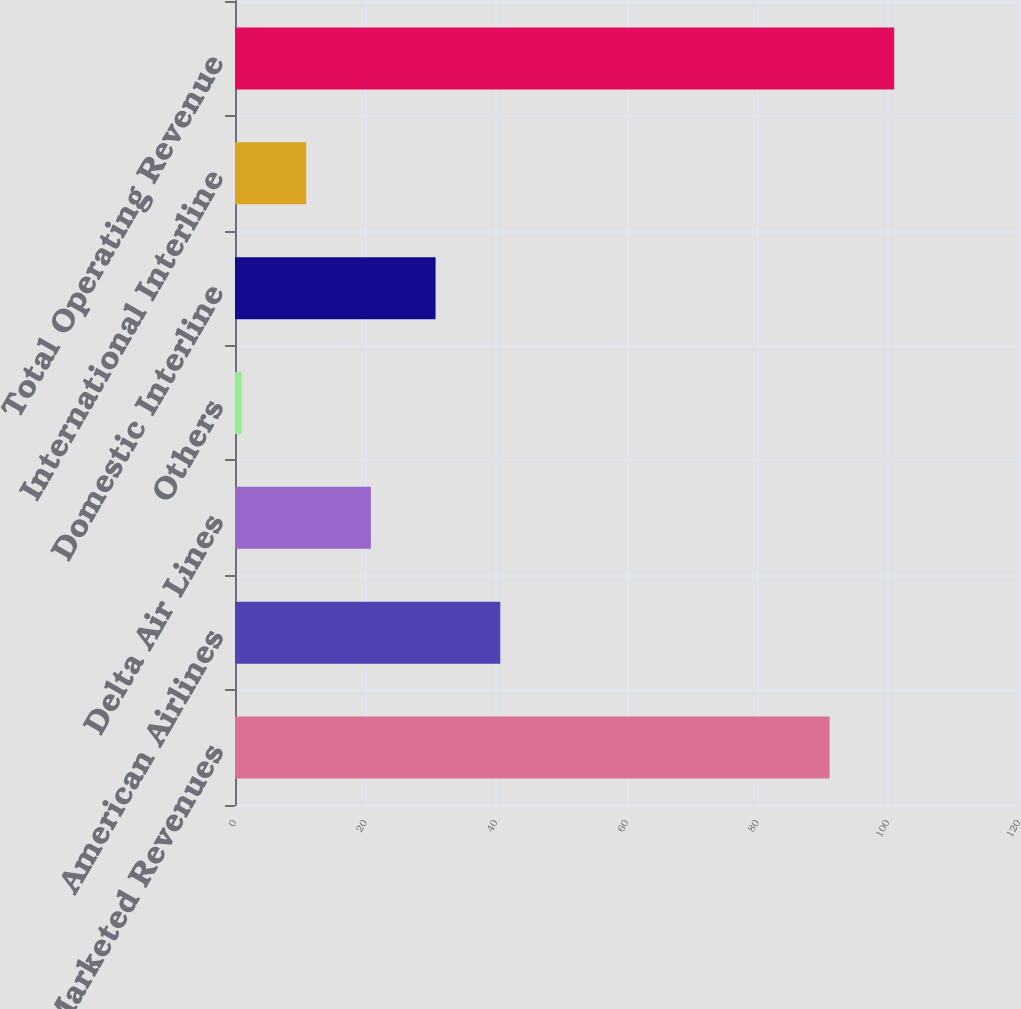Convert chart. <chart><loc_0><loc_0><loc_500><loc_500><bar_chart><fcel>Air Group Marketed Revenues<fcel>American Airlines<fcel>Delta Air Lines<fcel>Others<fcel>Domestic Interline<fcel>International Interline<fcel>Total Operating Revenue<nl><fcel>91<fcel>40.6<fcel>20.8<fcel>1<fcel>30.7<fcel>10.9<fcel>100.9<nl></chart> 